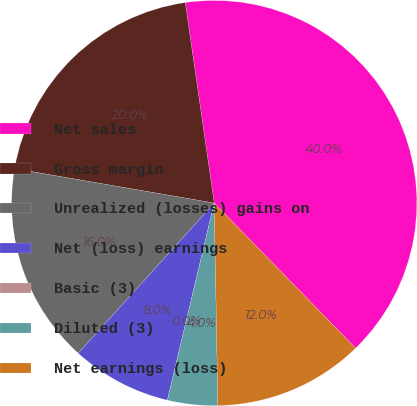Convert chart to OTSL. <chart><loc_0><loc_0><loc_500><loc_500><pie_chart><fcel>Net sales<fcel>Gross margin<fcel>Unrealized (losses) gains on<fcel>Net (loss) earnings<fcel>Basic (3)<fcel>Diluted (3)<fcel>Net earnings (loss)<nl><fcel>39.99%<fcel>20.0%<fcel>16.0%<fcel>8.0%<fcel>0.0%<fcel>4.0%<fcel>12.0%<nl></chart> 